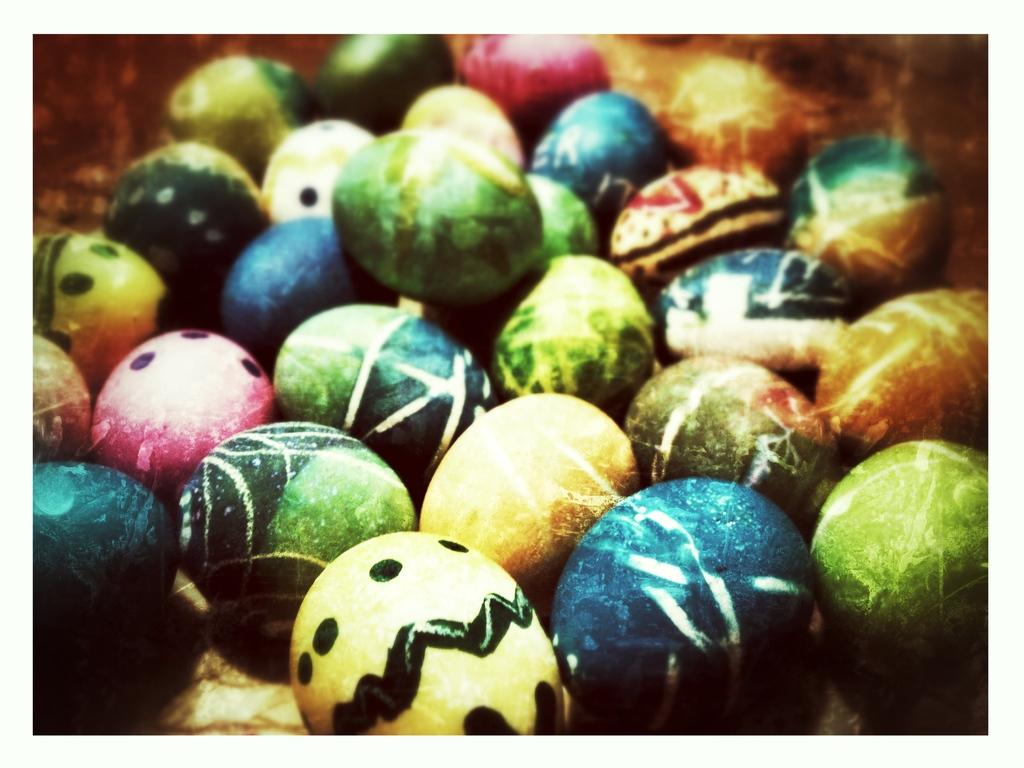What type of objects are present in the image? There are colorful eggs in the image. Can you describe the appearance of the eggs? The eggs are colorful, which suggests they may have been decorated or dyed. What might be the occasion for having these colorful eggs? The colorful eggs could be associated with Easter or another cultural or religious celebration. What type of agreement was reached during the cannon firing in the image? There is no cannon firing or agreement present in the image; it only features colorful eggs. 